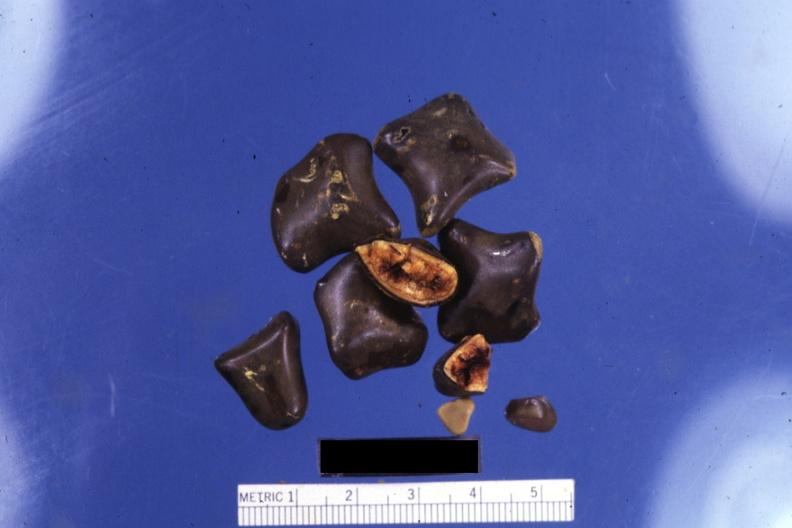what is present?
Answer the question using a single word or phrase. Hepatobiliary 